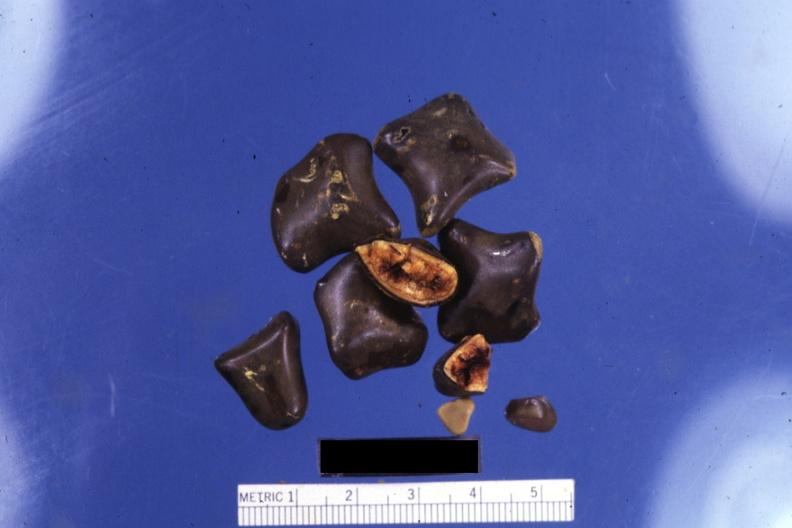what is present?
Answer the question using a single word or phrase. Hepatobiliary 